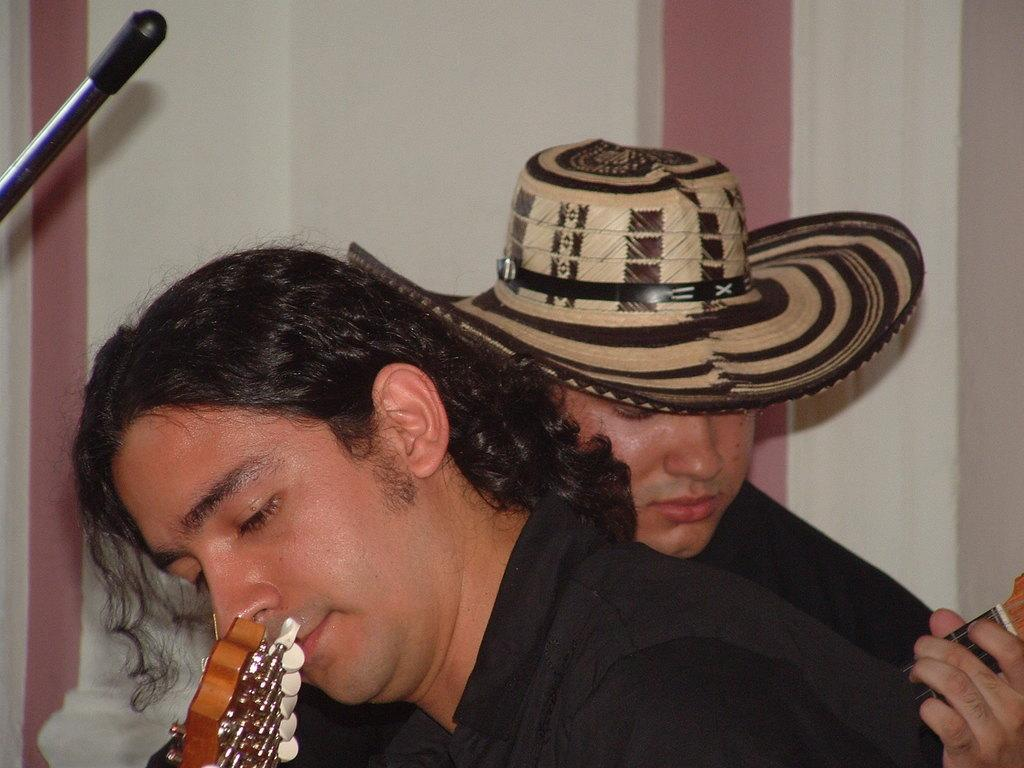How many people are in the image? There are two persons in the image. What are the two persons doing in the image? The two persons are playing musical instruments. Where are the two persons located in the image? The two persons are near a wall. What can be seen on the left side of the image? There is an object on the left side of the image. What type of knowledge can be gained from the sticks in the image? There are no sticks present in the image, so no knowledge can be gained from them. 